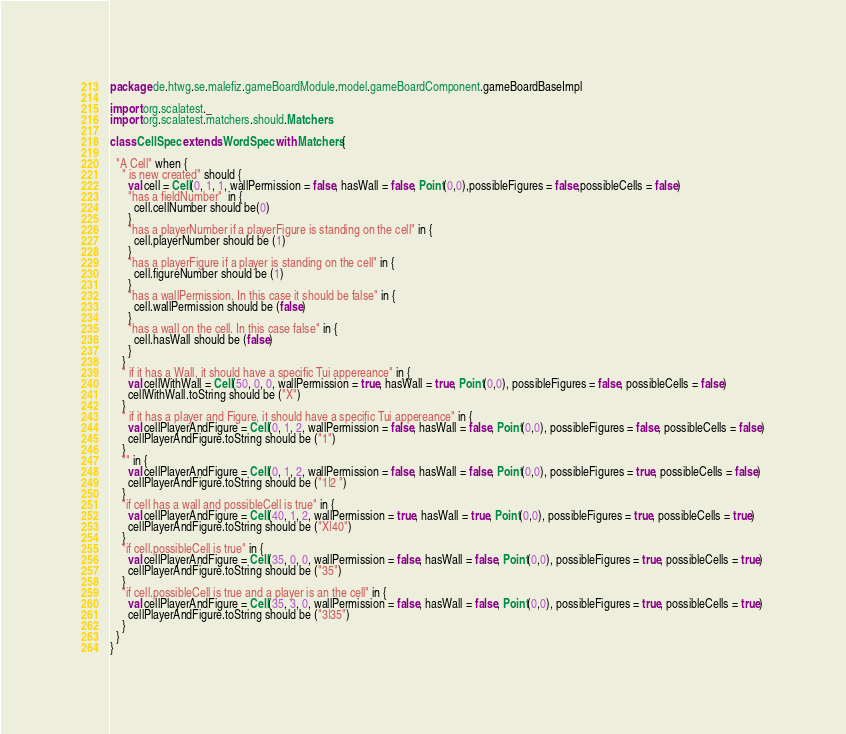<code> <loc_0><loc_0><loc_500><loc_500><_Scala_>package de.htwg.se.malefiz.gameBoardModule.model.gameBoardComponent.gameBoardBaseImpl

import org.scalatest._
import org.scalatest.matchers.should.Matchers

class CellSpec extends WordSpec with Matchers{

  "A Cell" when {
    " is new created" should {
      val cell = Cell(0, 1, 1, wallPermission = false, hasWall = false, Point(0,0),possibleFigures = false,possibleCells = false)
      "has a fieldNumber"  in {
        cell.cellNumber should be(0)
      }
      "has a playerNumber if a playerFigure is standing on the cell" in {
        cell.playerNumber should be (1)
      }
      "has a playerFigure if a player is standing on the cell" in {
        cell.figureNumber should be (1)
      }
      "has a wallPermission. In this case it should be false" in {
        cell.wallPermission should be (false)
      }
      "has a wall on the cell. In this case false" in {
        cell.hasWall should be (false)
      }
    }
    " if it has a Wall, it should have a specific Tui appereance" in {
      val cellWithWall = Cell(50, 0, 0, wallPermission = true, hasWall = true, Point(0,0), possibleFigures = false, possibleCells = false)
      cellWithWall.toString should be ("X")
    }
    " if it has a player and Figure, it should have a specific Tui appereance" in {
      val cellPlayerAndFigure = Cell(0, 1, 2, wallPermission = false, hasWall = false, Point(0,0), possibleFigures = false, possibleCells = false)
      cellPlayerAndFigure.toString should be ("1")
    }
    "" in {
      val cellPlayerAndFigure = Cell(0, 1, 2, wallPermission = false, hasWall = false, Point(0,0), possibleFigures = true, possibleCells = false)
      cellPlayerAndFigure.toString should be ("1|2 ")
    }
    "if cell has a wall and possibleCell is true" in {
      val cellPlayerAndFigure = Cell(40, 1, 2, wallPermission = true, hasWall = true, Point(0,0), possibleFigures = true, possibleCells = true)
      cellPlayerAndFigure.toString should be ("X|40")
    }
    "if cell.possibleCell is true" in {
      val cellPlayerAndFigure = Cell(35, 0, 0, wallPermission = false, hasWall = false, Point(0,0), possibleFigures = true, possibleCells = true)
      cellPlayerAndFigure.toString should be ("35")
    }
    "if cell.possibleCell is true and a player is an the cell" in {
      val cellPlayerAndFigure = Cell(35, 3, 0, wallPermission = false, hasWall = false, Point(0,0), possibleFigures = true, possibleCells = true)
      cellPlayerAndFigure.toString should be ("3|35")
    }
  }
}
</code> 